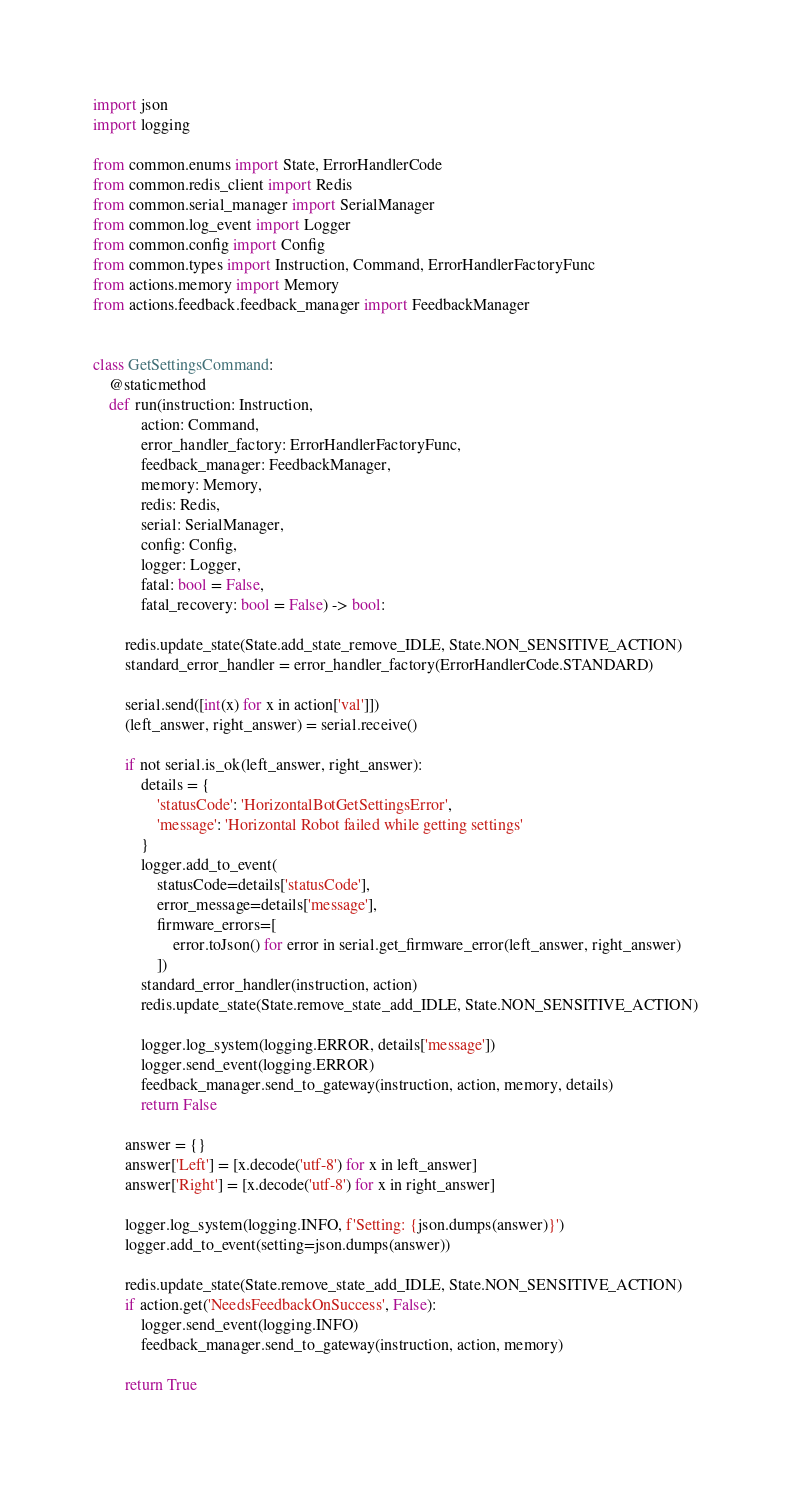<code> <loc_0><loc_0><loc_500><loc_500><_Python_>import json
import logging

from common.enums import State, ErrorHandlerCode
from common.redis_client import Redis
from common.serial_manager import SerialManager
from common.log_event import Logger
from common.config import Config
from common.types import Instruction, Command, ErrorHandlerFactoryFunc
from actions.memory import Memory
from actions.feedback.feedback_manager import FeedbackManager


class GetSettingsCommand:
    @staticmethod
    def run(instruction: Instruction,
            action: Command,
            error_handler_factory: ErrorHandlerFactoryFunc,
            feedback_manager: FeedbackManager,
            memory: Memory,
            redis: Redis,
            serial: SerialManager,
            config: Config,
            logger: Logger,
            fatal: bool = False,
            fatal_recovery: bool = False) -> bool:

        redis.update_state(State.add_state_remove_IDLE, State.NON_SENSITIVE_ACTION)
        standard_error_handler = error_handler_factory(ErrorHandlerCode.STANDARD)

        serial.send([int(x) for x in action['val']])
        (left_answer, right_answer) = serial.receive()

        if not serial.is_ok(left_answer, right_answer):
            details = {
                'statusCode': 'HorizontalBotGetSettingsError',
                'message': 'Horizontal Robot failed while getting settings'
            }
            logger.add_to_event(
                statusCode=details['statusCode'],
                error_message=details['message'],
                firmware_errors=[
                    error.toJson() for error in serial.get_firmware_error(left_answer, right_answer)
                ])
            standard_error_handler(instruction, action)
            redis.update_state(State.remove_state_add_IDLE, State.NON_SENSITIVE_ACTION)

            logger.log_system(logging.ERROR, details['message'])
            logger.send_event(logging.ERROR)
            feedback_manager.send_to_gateway(instruction, action, memory, details)
            return False

        answer = {}
        answer['Left'] = [x.decode('utf-8') for x in left_answer]
        answer['Right'] = [x.decode('utf-8') for x in right_answer]

        logger.log_system(logging.INFO, f'Setting: {json.dumps(answer)}')
        logger.add_to_event(setting=json.dumps(answer))

        redis.update_state(State.remove_state_add_IDLE, State.NON_SENSITIVE_ACTION)
        if action.get('NeedsFeedbackOnSuccess', False):
            logger.send_event(logging.INFO)
            feedback_manager.send_to_gateway(instruction, action, memory)

        return True
</code> 